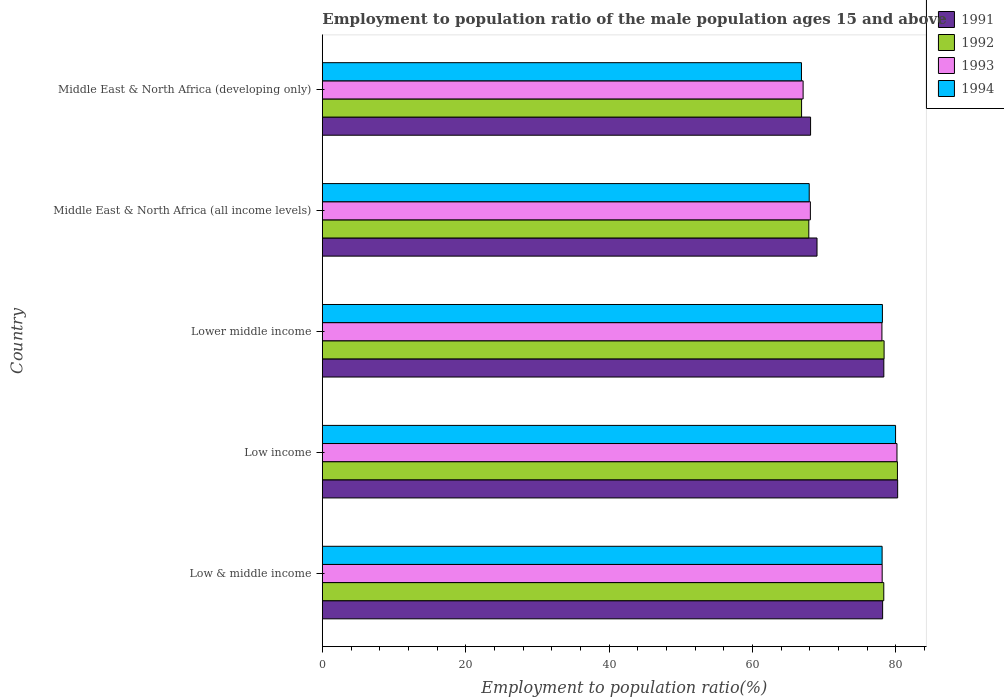Are the number of bars per tick equal to the number of legend labels?
Make the answer very short. Yes. How many bars are there on the 1st tick from the top?
Your answer should be compact. 4. What is the label of the 2nd group of bars from the top?
Provide a short and direct response. Middle East & North Africa (all income levels). In how many cases, is the number of bars for a given country not equal to the number of legend labels?
Offer a terse response. 0. What is the employment to population ratio in 1991 in Middle East & North Africa (developing only)?
Give a very brief answer. 68.09. Across all countries, what is the maximum employment to population ratio in 1992?
Ensure brevity in your answer.  80.2. Across all countries, what is the minimum employment to population ratio in 1992?
Provide a short and direct response. 66.83. In which country was the employment to population ratio in 1994 minimum?
Ensure brevity in your answer.  Middle East & North Africa (developing only). What is the total employment to population ratio in 1993 in the graph?
Your answer should be very brief. 371.35. What is the difference between the employment to population ratio in 1994 in Low income and that in Middle East & North Africa (developing only)?
Keep it short and to the point. 13.12. What is the difference between the employment to population ratio in 1993 in Middle East & North Africa (all income levels) and the employment to population ratio in 1991 in Low income?
Keep it short and to the point. -12.17. What is the average employment to population ratio in 1991 per country?
Ensure brevity in your answer.  74.75. What is the difference between the employment to population ratio in 1992 and employment to population ratio in 1994 in Lower middle income?
Offer a terse response. 0.24. What is the ratio of the employment to population ratio in 1994 in Low & middle income to that in Middle East & North Africa (developing only)?
Offer a very short reply. 1.17. Is the employment to population ratio in 1992 in Lower middle income less than that in Middle East & North Africa (all income levels)?
Ensure brevity in your answer.  No. What is the difference between the highest and the second highest employment to population ratio in 1991?
Make the answer very short. 1.93. What is the difference between the highest and the lowest employment to population ratio in 1991?
Ensure brevity in your answer.  12.14. In how many countries, is the employment to population ratio in 1991 greater than the average employment to population ratio in 1991 taken over all countries?
Provide a short and direct response. 3. Is the sum of the employment to population ratio in 1992 in Middle East & North Africa (all income levels) and Middle East & North Africa (developing only) greater than the maximum employment to population ratio in 1993 across all countries?
Your answer should be compact. Yes. What does the 3rd bar from the bottom in Middle East & North Africa (all income levels) represents?
Offer a very short reply. 1993. Is it the case that in every country, the sum of the employment to population ratio in 1991 and employment to population ratio in 1994 is greater than the employment to population ratio in 1992?
Your response must be concise. Yes. How many bars are there?
Provide a succinct answer. 20. Does the graph contain any zero values?
Your response must be concise. No. Where does the legend appear in the graph?
Give a very brief answer. Top right. How many legend labels are there?
Make the answer very short. 4. What is the title of the graph?
Provide a short and direct response. Employment to population ratio of the male population ages 15 and above. Does "2007" appear as one of the legend labels in the graph?
Provide a short and direct response. No. What is the label or title of the Y-axis?
Keep it short and to the point. Country. What is the Employment to population ratio(%) in 1991 in Low & middle income?
Your response must be concise. 78.14. What is the Employment to population ratio(%) in 1992 in Low & middle income?
Offer a terse response. 78.3. What is the Employment to population ratio(%) in 1993 in Low & middle income?
Make the answer very short. 78.07. What is the Employment to population ratio(%) in 1994 in Low & middle income?
Your answer should be compact. 78.06. What is the Employment to population ratio(%) in 1991 in Low income?
Offer a terse response. 80.23. What is the Employment to population ratio(%) in 1992 in Low income?
Give a very brief answer. 80.2. What is the Employment to population ratio(%) of 1993 in Low income?
Provide a short and direct response. 80.14. What is the Employment to population ratio(%) in 1994 in Low income?
Offer a terse response. 79.94. What is the Employment to population ratio(%) in 1991 in Lower middle income?
Offer a terse response. 78.3. What is the Employment to population ratio(%) in 1992 in Lower middle income?
Provide a short and direct response. 78.34. What is the Employment to population ratio(%) in 1993 in Lower middle income?
Make the answer very short. 78.04. What is the Employment to population ratio(%) in 1994 in Lower middle income?
Your answer should be compact. 78.11. What is the Employment to population ratio(%) in 1991 in Middle East & North Africa (all income levels)?
Your response must be concise. 68.99. What is the Employment to population ratio(%) in 1992 in Middle East & North Africa (all income levels)?
Your answer should be very brief. 67.84. What is the Employment to population ratio(%) of 1993 in Middle East & North Africa (all income levels)?
Keep it short and to the point. 68.06. What is the Employment to population ratio(%) in 1994 in Middle East & North Africa (all income levels)?
Offer a very short reply. 67.9. What is the Employment to population ratio(%) of 1991 in Middle East & North Africa (developing only)?
Your answer should be compact. 68.09. What is the Employment to population ratio(%) of 1992 in Middle East & North Africa (developing only)?
Keep it short and to the point. 66.83. What is the Employment to population ratio(%) of 1993 in Middle East & North Africa (developing only)?
Keep it short and to the point. 67.05. What is the Employment to population ratio(%) in 1994 in Middle East & North Africa (developing only)?
Provide a succinct answer. 66.82. Across all countries, what is the maximum Employment to population ratio(%) in 1991?
Make the answer very short. 80.23. Across all countries, what is the maximum Employment to population ratio(%) of 1992?
Ensure brevity in your answer.  80.2. Across all countries, what is the maximum Employment to population ratio(%) in 1993?
Your answer should be compact. 80.14. Across all countries, what is the maximum Employment to population ratio(%) in 1994?
Give a very brief answer. 79.94. Across all countries, what is the minimum Employment to population ratio(%) in 1991?
Keep it short and to the point. 68.09. Across all countries, what is the minimum Employment to population ratio(%) in 1992?
Keep it short and to the point. 66.83. Across all countries, what is the minimum Employment to population ratio(%) in 1993?
Offer a very short reply. 67.05. Across all countries, what is the minimum Employment to population ratio(%) in 1994?
Keep it short and to the point. 66.82. What is the total Employment to population ratio(%) in 1991 in the graph?
Your answer should be very brief. 373.75. What is the total Employment to population ratio(%) in 1992 in the graph?
Give a very brief answer. 371.51. What is the total Employment to population ratio(%) of 1993 in the graph?
Offer a terse response. 371.35. What is the total Employment to population ratio(%) in 1994 in the graph?
Your answer should be compact. 370.83. What is the difference between the Employment to population ratio(%) in 1991 in Low & middle income and that in Low income?
Your answer should be compact. -2.1. What is the difference between the Employment to population ratio(%) in 1992 in Low & middle income and that in Low income?
Ensure brevity in your answer.  -1.9. What is the difference between the Employment to population ratio(%) of 1993 in Low & middle income and that in Low income?
Provide a succinct answer. -2.06. What is the difference between the Employment to population ratio(%) in 1994 in Low & middle income and that in Low income?
Provide a succinct answer. -1.88. What is the difference between the Employment to population ratio(%) of 1991 in Low & middle income and that in Lower middle income?
Your answer should be compact. -0.17. What is the difference between the Employment to population ratio(%) of 1992 in Low & middle income and that in Lower middle income?
Your answer should be very brief. -0.04. What is the difference between the Employment to population ratio(%) of 1993 in Low & middle income and that in Lower middle income?
Offer a very short reply. 0.04. What is the difference between the Employment to population ratio(%) of 1994 in Low & middle income and that in Lower middle income?
Your answer should be compact. -0.04. What is the difference between the Employment to population ratio(%) in 1991 in Low & middle income and that in Middle East & North Africa (all income levels)?
Ensure brevity in your answer.  9.15. What is the difference between the Employment to population ratio(%) of 1992 in Low & middle income and that in Middle East & North Africa (all income levels)?
Give a very brief answer. 10.46. What is the difference between the Employment to population ratio(%) in 1993 in Low & middle income and that in Middle East & North Africa (all income levels)?
Your answer should be very brief. 10.01. What is the difference between the Employment to population ratio(%) of 1994 in Low & middle income and that in Middle East & North Africa (all income levels)?
Provide a succinct answer. 10.17. What is the difference between the Employment to population ratio(%) of 1991 in Low & middle income and that in Middle East & North Africa (developing only)?
Your answer should be compact. 10.05. What is the difference between the Employment to population ratio(%) of 1992 in Low & middle income and that in Middle East & North Africa (developing only)?
Offer a very short reply. 11.46. What is the difference between the Employment to population ratio(%) in 1993 in Low & middle income and that in Middle East & North Africa (developing only)?
Your response must be concise. 11.03. What is the difference between the Employment to population ratio(%) of 1994 in Low & middle income and that in Middle East & North Africa (developing only)?
Ensure brevity in your answer.  11.25. What is the difference between the Employment to population ratio(%) in 1991 in Low income and that in Lower middle income?
Give a very brief answer. 1.93. What is the difference between the Employment to population ratio(%) of 1992 in Low income and that in Lower middle income?
Your response must be concise. 1.86. What is the difference between the Employment to population ratio(%) in 1993 in Low income and that in Lower middle income?
Provide a succinct answer. 2.1. What is the difference between the Employment to population ratio(%) in 1994 in Low income and that in Lower middle income?
Offer a very short reply. 1.84. What is the difference between the Employment to population ratio(%) in 1991 in Low income and that in Middle East & North Africa (all income levels)?
Give a very brief answer. 11.25. What is the difference between the Employment to population ratio(%) of 1992 in Low income and that in Middle East & North Africa (all income levels)?
Keep it short and to the point. 12.36. What is the difference between the Employment to population ratio(%) of 1993 in Low income and that in Middle East & North Africa (all income levels)?
Provide a short and direct response. 12.08. What is the difference between the Employment to population ratio(%) of 1994 in Low income and that in Middle East & North Africa (all income levels)?
Your answer should be very brief. 12.04. What is the difference between the Employment to population ratio(%) of 1991 in Low income and that in Middle East & North Africa (developing only)?
Give a very brief answer. 12.14. What is the difference between the Employment to population ratio(%) in 1992 in Low income and that in Middle East & North Africa (developing only)?
Provide a succinct answer. 13.37. What is the difference between the Employment to population ratio(%) in 1993 in Low income and that in Middle East & North Africa (developing only)?
Offer a terse response. 13.09. What is the difference between the Employment to population ratio(%) of 1994 in Low income and that in Middle East & North Africa (developing only)?
Keep it short and to the point. 13.12. What is the difference between the Employment to population ratio(%) in 1991 in Lower middle income and that in Middle East & North Africa (all income levels)?
Your answer should be compact. 9.32. What is the difference between the Employment to population ratio(%) of 1992 in Lower middle income and that in Middle East & North Africa (all income levels)?
Give a very brief answer. 10.5. What is the difference between the Employment to population ratio(%) in 1993 in Lower middle income and that in Middle East & North Africa (all income levels)?
Provide a succinct answer. 9.98. What is the difference between the Employment to population ratio(%) in 1994 in Lower middle income and that in Middle East & North Africa (all income levels)?
Make the answer very short. 10.21. What is the difference between the Employment to population ratio(%) of 1991 in Lower middle income and that in Middle East & North Africa (developing only)?
Provide a short and direct response. 10.21. What is the difference between the Employment to population ratio(%) of 1992 in Lower middle income and that in Middle East & North Africa (developing only)?
Your answer should be very brief. 11.51. What is the difference between the Employment to population ratio(%) in 1993 in Lower middle income and that in Middle East & North Africa (developing only)?
Ensure brevity in your answer.  10.99. What is the difference between the Employment to population ratio(%) of 1994 in Lower middle income and that in Middle East & North Africa (developing only)?
Make the answer very short. 11.29. What is the difference between the Employment to population ratio(%) in 1991 in Middle East & North Africa (all income levels) and that in Middle East & North Africa (developing only)?
Offer a terse response. 0.9. What is the difference between the Employment to population ratio(%) in 1992 in Middle East & North Africa (all income levels) and that in Middle East & North Africa (developing only)?
Offer a terse response. 1.01. What is the difference between the Employment to population ratio(%) of 1993 in Middle East & North Africa (all income levels) and that in Middle East & North Africa (developing only)?
Offer a very short reply. 1.01. What is the difference between the Employment to population ratio(%) in 1994 in Middle East & North Africa (all income levels) and that in Middle East & North Africa (developing only)?
Make the answer very short. 1.08. What is the difference between the Employment to population ratio(%) in 1991 in Low & middle income and the Employment to population ratio(%) in 1992 in Low income?
Your response must be concise. -2.06. What is the difference between the Employment to population ratio(%) of 1991 in Low & middle income and the Employment to population ratio(%) of 1993 in Low income?
Provide a short and direct response. -2. What is the difference between the Employment to population ratio(%) in 1991 in Low & middle income and the Employment to population ratio(%) in 1994 in Low income?
Ensure brevity in your answer.  -1.8. What is the difference between the Employment to population ratio(%) of 1992 in Low & middle income and the Employment to population ratio(%) of 1993 in Low income?
Offer a terse response. -1.84. What is the difference between the Employment to population ratio(%) of 1992 in Low & middle income and the Employment to population ratio(%) of 1994 in Low income?
Your answer should be compact. -1.64. What is the difference between the Employment to population ratio(%) in 1993 in Low & middle income and the Employment to population ratio(%) in 1994 in Low income?
Offer a very short reply. -1.87. What is the difference between the Employment to population ratio(%) in 1991 in Low & middle income and the Employment to population ratio(%) in 1992 in Lower middle income?
Your response must be concise. -0.21. What is the difference between the Employment to population ratio(%) in 1991 in Low & middle income and the Employment to population ratio(%) in 1993 in Lower middle income?
Provide a succinct answer. 0.1. What is the difference between the Employment to population ratio(%) of 1991 in Low & middle income and the Employment to population ratio(%) of 1994 in Lower middle income?
Offer a terse response. 0.03. What is the difference between the Employment to population ratio(%) of 1992 in Low & middle income and the Employment to population ratio(%) of 1993 in Lower middle income?
Your answer should be compact. 0.26. What is the difference between the Employment to population ratio(%) of 1992 in Low & middle income and the Employment to population ratio(%) of 1994 in Lower middle income?
Make the answer very short. 0.19. What is the difference between the Employment to population ratio(%) of 1993 in Low & middle income and the Employment to population ratio(%) of 1994 in Lower middle income?
Your answer should be compact. -0.03. What is the difference between the Employment to population ratio(%) of 1991 in Low & middle income and the Employment to population ratio(%) of 1992 in Middle East & North Africa (all income levels)?
Offer a very short reply. 10.29. What is the difference between the Employment to population ratio(%) of 1991 in Low & middle income and the Employment to population ratio(%) of 1993 in Middle East & North Africa (all income levels)?
Your response must be concise. 10.08. What is the difference between the Employment to population ratio(%) in 1991 in Low & middle income and the Employment to population ratio(%) in 1994 in Middle East & North Africa (all income levels)?
Give a very brief answer. 10.24. What is the difference between the Employment to population ratio(%) of 1992 in Low & middle income and the Employment to population ratio(%) of 1993 in Middle East & North Africa (all income levels)?
Make the answer very short. 10.24. What is the difference between the Employment to population ratio(%) in 1992 in Low & middle income and the Employment to population ratio(%) in 1994 in Middle East & North Africa (all income levels)?
Make the answer very short. 10.4. What is the difference between the Employment to population ratio(%) in 1993 in Low & middle income and the Employment to population ratio(%) in 1994 in Middle East & North Africa (all income levels)?
Your answer should be very brief. 10.17. What is the difference between the Employment to population ratio(%) of 1991 in Low & middle income and the Employment to population ratio(%) of 1992 in Middle East & North Africa (developing only)?
Make the answer very short. 11.3. What is the difference between the Employment to population ratio(%) in 1991 in Low & middle income and the Employment to population ratio(%) in 1993 in Middle East & North Africa (developing only)?
Offer a very short reply. 11.09. What is the difference between the Employment to population ratio(%) of 1991 in Low & middle income and the Employment to population ratio(%) of 1994 in Middle East & North Africa (developing only)?
Provide a succinct answer. 11.32. What is the difference between the Employment to population ratio(%) in 1992 in Low & middle income and the Employment to population ratio(%) in 1993 in Middle East & North Africa (developing only)?
Provide a short and direct response. 11.25. What is the difference between the Employment to population ratio(%) in 1992 in Low & middle income and the Employment to population ratio(%) in 1994 in Middle East & North Africa (developing only)?
Make the answer very short. 11.48. What is the difference between the Employment to population ratio(%) of 1993 in Low & middle income and the Employment to population ratio(%) of 1994 in Middle East & North Africa (developing only)?
Provide a succinct answer. 11.25. What is the difference between the Employment to population ratio(%) of 1991 in Low income and the Employment to population ratio(%) of 1992 in Lower middle income?
Provide a succinct answer. 1.89. What is the difference between the Employment to population ratio(%) in 1991 in Low income and the Employment to population ratio(%) in 1993 in Lower middle income?
Your answer should be very brief. 2.2. What is the difference between the Employment to population ratio(%) of 1991 in Low income and the Employment to population ratio(%) of 1994 in Lower middle income?
Give a very brief answer. 2.13. What is the difference between the Employment to population ratio(%) of 1992 in Low income and the Employment to population ratio(%) of 1993 in Lower middle income?
Ensure brevity in your answer.  2.16. What is the difference between the Employment to population ratio(%) of 1992 in Low income and the Employment to population ratio(%) of 1994 in Lower middle income?
Provide a short and direct response. 2.1. What is the difference between the Employment to population ratio(%) in 1993 in Low income and the Employment to population ratio(%) in 1994 in Lower middle income?
Offer a very short reply. 2.03. What is the difference between the Employment to population ratio(%) of 1991 in Low income and the Employment to population ratio(%) of 1992 in Middle East & North Africa (all income levels)?
Ensure brevity in your answer.  12.39. What is the difference between the Employment to population ratio(%) in 1991 in Low income and the Employment to population ratio(%) in 1993 in Middle East & North Africa (all income levels)?
Offer a terse response. 12.17. What is the difference between the Employment to population ratio(%) in 1991 in Low income and the Employment to population ratio(%) in 1994 in Middle East & North Africa (all income levels)?
Your answer should be very brief. 12.33. What is the difference between the Employment to population ratio(%) of 1992 in Low income and the Employment to population ratio(%) of 1993 in Middle East & North Africa (all income levels)?
Your answer should be compact. 12.14. What is the difference between the Employment to population ratio(%) in 1992 in Low income and the Employment to population ratio(%) in 1994 in Middle East & North Africa (all income levels)?
Make the answer very short. 12.3. What is the difference between the Employment to population ratio(%) in 1993 in Low income and the Employment to population ratio(%) in 1994 in Middle East & North Africa (all income levels)?
Your answer should be compact. 12.24. What is the difference between the Employment to population ratio(%) in 1991 in Low income and the Employment to population ratio(%) in 1992 in Middle East & North Africa (developing only)?
Give a very brief answer. 13.4. What is the difference between the Employment to population ratio(%) in 1991 in Low income and the Employment to population ratio(%) in 1993 in Middle East & North Africa (developing only)?
Provide a short and direct response. 13.19. What is the difference between the Employment to population ratio(%) in 1991 in Low income and the Employment to population ratio(%) in 1994 in Middle East & North Africa (developing only)?
Offer a terse response. 13.42. What is the difference between the Employment to population ratio(%) in 1992 in Low income and the Employment to population ratio(%) in 1993 in Middle East & North Africa (developing only)?
Ensure brevity in your answer.  13.15. What is the difference between the Employment to population ratio(%) of 1992 in Low income and the Employment to population ratio(%) of 1994 in Middle East & North Africa (developing only)?
Provide a succinct answer. 13.38. What is the difference between the Employment to population ratio(%) in 1993 in Low income and the Employment to population ratio(%) in 1994 in Middle East & North Africa (developing only)?
Give a very brief answer. 13.32. What is the difference between the Employment to population ratio(%) of 1991 in Lower middle income and the Employment to population ratio(%) of 1992 in Middle East & North Africa (all income levels)?
Keep it short and to the point. 10.46. What is the difference between the Employment to population ratio(%) of 1991 in Lower middle income and the Employment to population ratio(%) of 1993 in Middle East & North Africa (all income levels)?
Offer a very short reply. 10.24. What is the difference between the Employment to population ratio(%) of 1991 in Lower middle income and the Employment to population ratio(%) of 1994 in Middle East & North Africa (all income levels)?
Your response must be concise. 10.41. What is the difference between the Employment to population ratio(%) of 1992 in Lower middle income and the Employment to population ratio(%) of 1993 in Middle East & North Africa (all income levels)?
Ensure brevity in your answer.  10.28. What is the difference between the Employment to population ratio(%) of 1992 in Lower middle income and the Employment to population ratio(%) of 1994 in Middle East & North Africa (all income levels)?
Provide a succinct answer. 10.44. What is the difference between the Employment to population ratio(%) in 1993 in Lower middle income and the Employment to population ratio(%) in 1994 in Middle East & North Africa (all income levels)?
Provide a succinct answer. 10.14. What is the difference between the Employment to population ratio(%) of 1991 in Lower middle income and the Employment to population ratio(%) of 1992 in Middle East & North Africa (developing only)?
Your response must be concise. 11.47. What is the difference between the Employment to population ratio(%) of 1991 in Lower middle income and the Employment to population ratio(%) of 1993 in Middle East & North Africa (developing only)?
Your response must be concise. 11.26. What is the difference between the Employment to population ratio(%) in 1991 in Lower middle income and the Employment to population ratio(%) in 1994 in Middle East & North Africa (developing only)?
Ensure brevity in your answer.  11.49. What is the difference between the Employment to population ratio(%) of 1992 in Lower middle income and the Employment to population ratio(%) of 1993 in Middle East & North Africa (developing only)?
Your answer should be compact. 11.29. What is the difference between the Employment to population ratio(%) of 1992 in Lower middle income and the Employment to population ratio(%) of 1994 in Middle East & North Africa (developing only)?
Give a very brief answer. 11.52. What is the difference between the Employment to population ratio(%) of 1993 in Lower middle income and the Employment to population ratio(%) of 1994 in Middle East & North Africa (developing only)?
Make the answer very short. 11.22. What is the difference between the Employment to population ratio(%) in 1991 in Middle East & North Africa (all income levels) and the Employment to population ratio(%) in 1992 in Middle East & North Africa (developing only)?
Your response must be concise. 2.15. What is the difference between the Employment to population ratio(%) in 1991 in Middle East & North Africa (all income levels) and the Employment to population ratio(%) in 1993 in Middle East & North Africa (developing only)?
Provide a short and direct response. 1.94. What is the difference between the Employment to population ratio(%) of 1991 in Middle East & North Africa (all income levels) and the Employment to population ratio(%) of 1994 in Middle East & North Africa (developing only)?
Your answer should be very brief. 2.17. What is the difference between the Employment to population ratio(%) in 1992 in Middle East & North Africa (all income levels) and the Employment to population ratio(%) in 1993 in Middle East & North Africa (developing only)?
Offer a terse response. 0.79. What is the difference between the Employment to population ratio(%) in 1992 in Middle East & North Africa (all income levels) and the Employment to population ratio(%) in 1994 in Middle East & North Africa (developing only)?
Give a very brief answer. 1.02. What is the difference between the Employment to population ratio(%) in 1993 in Middle East & North Africa (all income levels) and the Employment to population ratio(%) in 1994 in Middle East & North Africa (developing only)?
Your answer should be compact. 1.24. What is the average Employment to population ratio(%) in 1991 per country?
Your answer should be very brief. 74.75. What is the average Employment to population ratio(%) in 1992 per country?
Ensure brevity in your answer.  74.3. What is the average Employment to population ratio(%) of 1993 per country?
Ensure brevity in your answer.  74.27. What is the average Employment to population ratio(%) of 1994 per country?
Offer a very short reply. 74.17. What is the difference between the Employment to population ratio(%) of 1991 and Employment to population ratio(%) of 1992 in Low & middle income?
Your answer should be very brief. -0.16. What is the difference between the Employment to population ratio(%) in 1991 and Employment to population ratio(%) in 1993 in Low & middle income?
Offer a terse response. 0.06. What is the difference between the Employment to population ratio(%) in 1991 and Employment to population ratio(%) in 1994 in Low & middle income?
Make the answer very short. 0.07. What is the difference between the Employment to population ratio(%) in 1992 and Employment to population ratio(%) in 1993 in Low & middle income?
Your response must be concise. 0.22. What is the difference between the Employment to population ratio(%) in 1992 and Employment to population ratio(%) in 1994 in Low & middle income?
Provide a short and direct response. 0.23. What is the difference between the Employment to population ratio(%) of 1993 and Employment to population ratio(%) of 1994 in Low & middle income?
Give a very brief answer. 0.01. What is the difference between the Employment to population ratio(%) in 1991 and Employment to population ratio(%) in 1992 in Low income?
Your answer should be compact. 0.03. What is the difference between the Employment to population ratio(%) in 1991 and Employment to population ratio(%) in 1993 in Low income?
Provide a short and direct response. 0.1. What is the difference between the Employment to population ratio(%) of 1991 and Employment to population ratio(%) of 1994 in Low income?
Give a very brief answer. 0.29. What is the difference between the Employment to population ratio(%) of 1992 and Employment to population ratio(%) of 1993 in Low income?
Make the answer very short. 0.06. What is the difference between the Employment to population ratio(%) of 1992 and Employment to population ratio(%) of 1994 in Low income?
Provide a short and direct response. 0.26. What is the difference between the Employment to population ratio(%) of 1993 and Employment to population ratio(%) of 1994 in Low income?
Keep it short and to the point. 0.19. What is the difference between the Employment to population ratio(%) of 1991 and Employment to population ratio(%) of 1992 in Lower middle income?
Provide a succinct answer. -0.04. What is the difference between the Employment to population ratio(%) in 1991 and Employment to population ratio(%) in 1993 in Lower middle income?
Ensure brevity in your answer.  0.27. What is the difference between the Employment to population ratio(%) in 1991 and Employment to population ratio(%) in 1994 in Lower middle income?
Your answer should be very brief. 0.2. What is the difference between the Employment to population ratio(%) of 1992 and Employment to population ratio(%) of 1993 in Lower middle income?
Offer a very short reply. 0.3. What is the difference between the Employment to population ratio(%) of 1992 and Employment to population ratio(%) of 1994 in Lower middle income?
Offer a very short reply. 0.24. What is the difference between the Employment to population ratio(%) of 1993 and Employment to population ratio(%) of 1994 in Lower middle income?
Offer a very short reply. -0.07. What is the difference between the Employment to population ratio(%) in 1991 and Employment to population ratio(%) in 1992 in Middle East & North Africa (all income levels)?
Keep it short and to the point. 1.14. What is the difference between the Employment to population ratio(%) of 1991 and Employment to population ratio(%) of 1993 in Middle East & North Africa (all income levels)?
Your answer should be compact. 0.93. What is the difference between the Employment to population ratio(%) in 1991 and Employment to population ratio(%) in 1994 in Middle East & North Africa (all income levels)?
Ensure brevity in your answer.  1.09. What is the difference between the Employment to population ratio(%) in 1992 and Employment to population ratio(%) in 1993 in Middle East & North Africa (all income levels)?
Your response must be concise. -0.22. What is the difference between the Employment to population ratio(%) of 1992 and Employment to population ratio(%) of 1994 in Middle East & North Africa (all income levels)?
Ensure brevity in your answer.  -0.06. What is the difference between the Employment to population ratio(%) in 1993 and Employment to population ratio(%) in 1994 in Middle East & North Africa (all income levels)?
Ensure brevity in your answer.  0.16. What is the difference between the Employment to population ratio(%) of 1991 and Employment to population ratio(%) of 1992 in Middle East & North Africa (developing only)?
Keep it short and to the point. 1.26. What is the difference between the Employment to population ratio(%) of 1991 and Employment to population ratio(%) of 1993 in Middle East & North Africa (developing only)?
Offer a very short reply. 1.04. What is the difference between the Employment to population ratio(%) in 1991 and Employment to population ratio(%) in 1994 in Middle East & North Africa (developing only)?
Offer a very short reply. 1.27. What is the difference between the Employment to population ratio(%) of 1992 and Employment to population ratio(%) of 1993 in Middle East & North Africa (developing only)?
Offer a very short reply. -0.21. What is the difference between the Employment to population ratio(%) of 1992 and Employment to population ratio(%) of 1994 in Middle East & North Africa (developing only)?
Your response must be concise. 0.01. What is the difference between the Employment to population ratio(%) in 1993 and Employment to population ratio(%) in 1994 in Middle East & North Africa (developing only)?
Provide a succinct answer. 0.23. What is the ratio of the Employment to population ratio(%) of 1991 in Low & middle income to that in Low income?
Offer a very short reply. 0.97. What is the ratio of the Employment to population ratio(%) in 1992 in Low & middle income to that in Low income?
Provide a short and direct response. 0.98. What is the ratio of the Employment to population ratio(%) in 1993 in Low & middle income to that in Low income?
Offer a very short reply. 0.97. What is the ratio of the Employment to population ratio(%) in 1994 in Low & middle income to that in Low income?
Your response must be concise. 0.98. What is the ratio of the Employment to population ratio(%) in 1991 in Low & middle income to that in Lower middle income?
Give a very brief answer. 1. What is the ratio of the Employment to population ratio(%) in 1991 in Low & middle income to that in Middle East & North Africa (all income levels)?
Keep it short and to the point. 1.13. What is the ratio of the Employment to population ratio(%) of 1992 in Low & middle income to that in Middle East & North Africa (all income levels)?
Provide a short and direct response. 1.15. What is the ratio of the Employment to population ratio(%) of 1993 in Low & middle income to that in Middle East & North Africa (all income levels)?
Your response must be concise. 1.15. What is the ratio of the Employment to population ratio(%) of 1994 in Low & middle income to that in Middle East & North Africa (all income levels)?
Your answer should be very brief. 1.15. What is the ratio of the Employment to population ratio(%) in 1991 in Low & middle income to that in Middle East & North Africa (developing only)?
Provide a short and direct response. 1.15. What is the ratio of the Employment to population ratio(%) of 1992 in Low & middle income to that in Middle East & North Africa (developing only)?
Your answer should be very brief. 1.17. What is the ratio of the Employment to population ratio(%) in 1993 in Low & middle income to that in Middle East & North Africa (developing only)?
Give a very brief answer. 1.16. What is the ratio of the Employment to population ratio(%) in 1994 in Low & middle income to that in Middle East & North Africa (developing only)?
Ensure brevity in your answer.  1.17. What is the ratio of the Employment to population ratio(%) of 1991 in Low income to that in Lower middle income?
Provide a short and direct response. 1.02. What is the ratio of the Employment to population ratio(%) in 1992 in Low income to that in Lower middle income?
Make the answer very short. 1.02. What is the ratio of the Employment to population ratio(%) in 1993 in Low income to that in Lower middle income?
Provide a succinct answer. 1.03. What is the ratio of the Employment to population ratio(%) in 1994 in Low income to that in Lower middle income?
Your answer should be compact. 1.02. What is the ratio of the Employment to population ratio(%) in 1991 in Low income to that in Middle East & North Africa (all income levels)?
Keep it short and to the point. 1.16. What is the ratio of the Employment to population ratio(%) of 1992 in Low income to that in Middle East & North Africa (all income levels)?
Offer a very short reply. 1.18. What is the ratio of the Employment to population ratio(%) in 1993 in Low income to that in Middle East & North Africa (all income levels)?
Your answer should be compact. 1.18. What is the ratio of the Employment to population ratio(%) of 1994 in Low income to that in Middle East & North Africa (all income levels)?
Ensure brevity in your answer.  1.18. What is the ratio of the Employment to population ratio(%) in 1991 in Low income to that in Middle East & North Africa (developing only)?
Your answer should be compact. 1.18. What is the ratio of the Employment to population ratio(%) in 1993 in Low income to that in Middle East & North Africa (developing only)?
Provide a succinct answer. 1.2. What is the ratio of the Employment to population ratio(%) of 1994 in Low income to that in Middle East & North Africa (developing only)?
Your answer should be very brief. 1.2. What is the ratio of the Employment to population ratio(%) in 1991 in Lower middle income to that in Middle East & North Africa (all income levels)?
Give a very brief answer. 1.14. What is the ratio of the Employment to population ratio(%) in 1992 in Lower middle income to that in Middle East & North Africa (all income levels)?
Offer a terse response. 1.15. What is the ratio of the Employment to population ratio(%) of 1993 in Lower middle income to that in Middle East & North Africa (all income levels)?
Offer a terse response. 1.15. What is the ratio of the Employment to population ratio(%) in 1994 in Lower middle income to that in Middle East & North Africa (all income levels)?
Provide a succinct answer. 1.15. What is the ratio of the Employment to population ratio(%) in 1991 in Lower middle income to that in Middle East & North Africa (developing only)?
Offer a terse response. 1.15. What is the ratio of the Employment to population ratio(%) in 1992 in Lower middle income to that in Middle East & North Africa (developing only)?
Give a very brief answer. 1.17. What is the ratio of the Employment to population ratio(%) in 1993 in Lower middle income to that in Middle East & North Africa (developing only)?
Give a very brief answer. 1.16. What is the ratio of the Employment to population ratio(%) of 1994 in Lower middle income to that in Middle East & North Africa (developing only)?
Make the answer very short. 1.17. What is the ratio of the Employment to population ratio(%) of 1991 in Middle East & North Africa (all income levels) to that in Middle East & North Africa (developing only)?
Ensure brevity in your answer.  1.01. What is the ratio of the Employment to population ratio(%) in 1992 in Middle East & North Africa (all income levels) to that in Middle East & North Africa (developing only)?
Your response must be concise. 1.02. What is the ratio of the Employment to population ratio(%) in 1993 in Middle East & North Africa (all income levels) to that in Middle East & North Africa (developing only)?
Give a very brief answer. 1.02. What is the ratio of the Employment to population ratio(%) in 1994 in Middle East & North Africa (all income levels) to that in Middle East & North Africa (developing only)?
Your answer should be very brief. 1.02. What is the difference between the highest and the second highest Employment to population ratio(%) of 1991?
Offer a terse response. 1.93. What is the difference between the highest and the second highest Employment to population ratio(%) of 1992?
Your answer should be compact. 1.86. What is the difference between the highest and the second highest Employment to population ratio(%) in 1993?
Keep it short and to the point. 2.06. What is the difference between the highest and the second highest Employment to population ratio(%) of 1994?
Give a very brief answer. 1.84. What is the difference between the highest and the lowest Employment to population ratio(%) in 1991?
Give a very brief answer. 12.14. What is the difference between the highest and the lowest Employment to population ratio(%) in 1992?
Offer a very short reply. 13.37. What is the difference between the highest and the lowest Employment to population ratio(%) in 1993?
Offer a terse response. 13.09. What is the difference between the highest and the lowest Employment to population ratio(%) of 1994?
Your response must be concise. 13.12. 